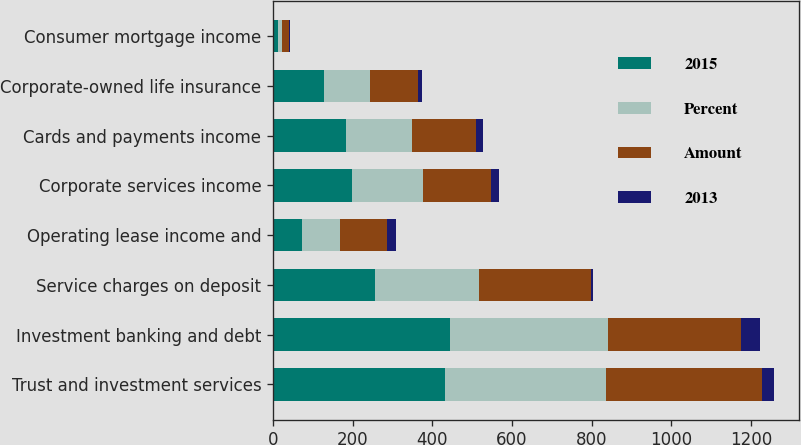<chart> <loc_0><loc_0><loc_500><loc_500><stacked_bar_chart><ecel><fcel>Trust and investment services<fcel>Investment banking and debt<fcel>Service charges on deposit<fcel>Operating lease income and<fcel>Corporate services income<fcel>Cards and payments income<fcel>Corporate-owned life insurance<fcel>Consumer mortgage income<nl><fcel>2015<fcel>433<fcel>445<fcel>256<fcel>73<fcel>198<fcel>183<fcel>127<fcel>12<nl><fcel>Percent<fcel>403<fcel>397<fcel>261<fcel>96<fcel>178<fcel>166<fcel>118<fcel>10<nl><fcel>Amount<fcel>393<fcel>333<fcel>281<fcel>117<fcel>172<fcel>162<fcel>120<fcel>19<nl><fcel>2013<fcel>30<fcel>48<fcel>5<fcel>23<fcel>20<fcel>17<fcel>9<fcel>2<nl></chart> 